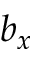<formula> <loc_0><loc_0><loc_500><loc_500>b _ { x }</formula> 